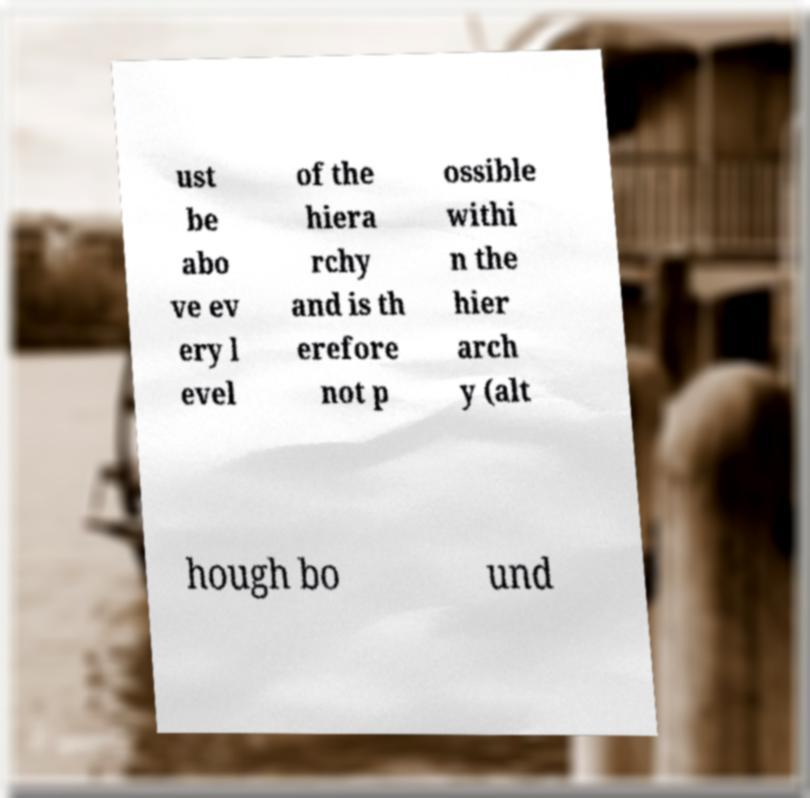Could you assist in decoding the text presented in this image and type it out clearly? ust be abo ve ev ery l evel of the hiera rchy and is th erefore not p ossible withi n the hier arch y (alt hough bo und 